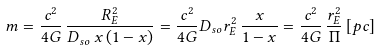<formula> <loc_0><loc_0><loc_500><loc_500>m = \frac { c ^ { 2 } } { 4 G } \, \frac { R _ { E } ^ { 2 } } { D _ { s o } \, x \, ( 1 - x ) } = \frac { c ^ { 2 } } { 4 G } D _ { s o } r _ { E } ^ { 2 } \, \frac { x } { 1 - x } = \frac { c ^ { 2 } } { 4 G } \, \frac { r _ { E } ^ { 2 } } { \Pi } \, [ p c ]</formula> 